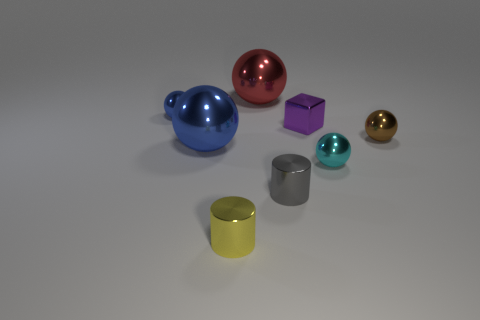Does the yellow shiny object have the same size as the blue shiny thing in front of the block?
Your response must be concise. No. What is the color of the large metal object in front of the small blue metal ball?
Offer a very short reply. Blue. The large thing that is to the left of the large red metal sphere has what shape?
Give a very brief answer. Sphere. How many blue objects are either big metal objects or tiny cylinders?
Give a very brief answer. 1. There is a brown shiny object; how many cyan balls are left of it?
Ensure brevity in your answer.  1. What number of cubes are either yellow objects or red things?
Offer a terse response. 0. What material is the cyan thing that is the same shape as the red shiny thing?
Make the answer very short. Metal. There is a cube that is made of the same material as the tiny yellow object; what size is it?
Offer a very short reply. Small. Is the shape of the blue thing that is behind the tiny purple block the same as the big shiny thing left of the tiny yellow object?
Ensure brevity in your answer.  Yes. There is another cylinder that is made of the same material as the gray cylinder; what is its color?
Offer a terse response. Yellow. 